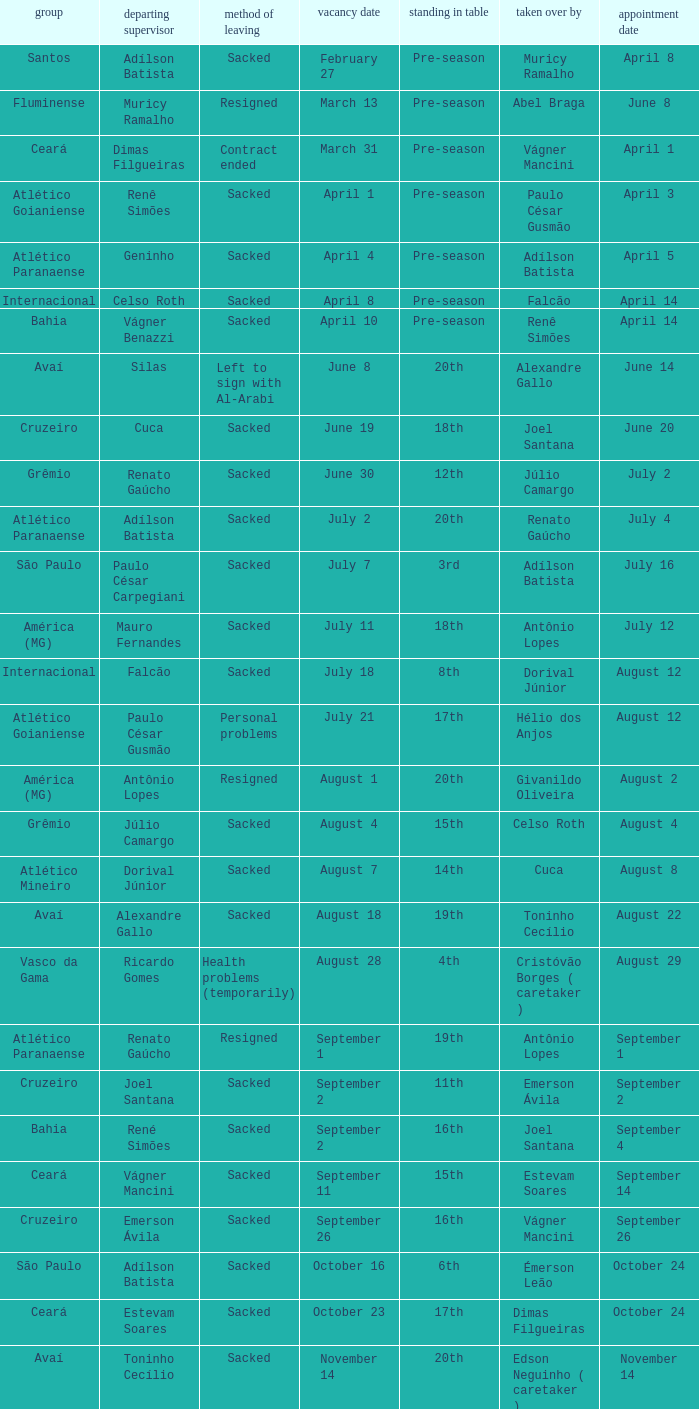Who was the new Santos manager? Muricy Ramalho. 